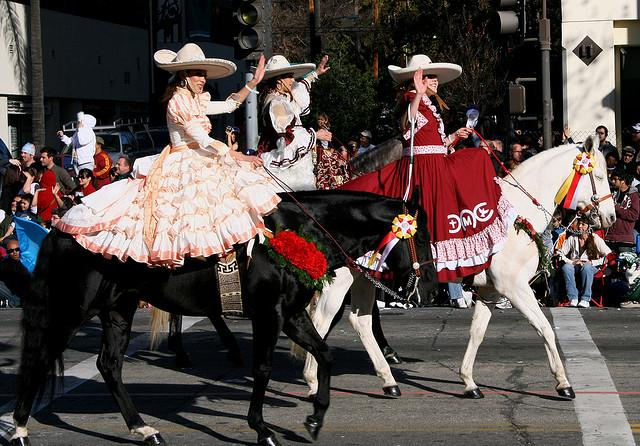What color is the woman's dress who is riding a white stallion?

Choices:
A) yellow
B) pink
C) green
D) red red 